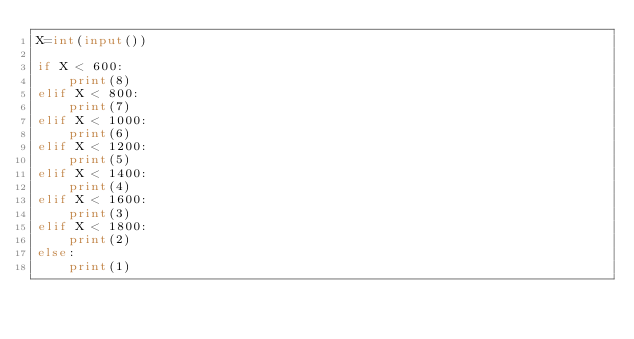<code> <loc_0><loc_0><loc_500><loc_500><_Python_>X=int(input())

if X < 600:
    print(8)
elif X < 800:
    print(7)
elif X < 1000:
    print(6)
elif X < 1200:
    print(5)
elif X < 1400:
    print(4)
elif X < 1600:
    print(3)
elif X < 1800:
    print(2)
else:
    print(1)</code> 